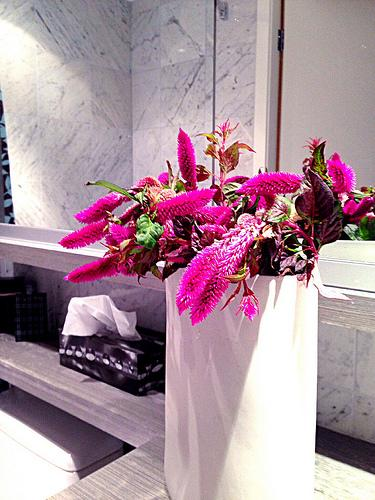What type of flowers are in the vase and what color is the vase? The vase is white and contains purple and pink flowers. Write a statement referring to the door and the hanger on the wall in the image. There is a large white door with a black hinge, and a hanger is hanging on the wall nearby. Describe the tissue box in the image. The tissue box is black and white with a white tissue coming out of it. In the format of a product advertisement, describe the vase with flowers in the image. Introducing our stunning white vase, elegantly displaying a bouquet of delightful pink and purple flowers. Enhance your decor today with this enchanting centerpiece! Mention one prominent feature of the wall in the image. The wall has a marbled pattern. When given this image, what objects are well-suited for a multi-choice VQA task? Objects well-suited for a multi-choice VQA task include the white vase, pink and purple flowers, marbled wall, tissue box, and toilet water basin. Provide a concise summary of the scene depicted in the image. The image shows a variety of objects, including a white vase with pink and purple flowers, a green leaf, a marbled wall, a tissue box, and a toilet water basin. Using posh language, describe the box of tissues and their placement. A box of monochrome tissues, adorned with polka dots, is elegantly positioned near the edge of a countertop. Name two tasks where the green leaf could be used in the referential expression grounding task. 2) Locate the object in the image positioned between the pink and purple flowers. Choose two objects from the image and state whether they match each other. A black cardboard box and the white tissue box with black dots appear to share a similar color scheme, complementing each other. 